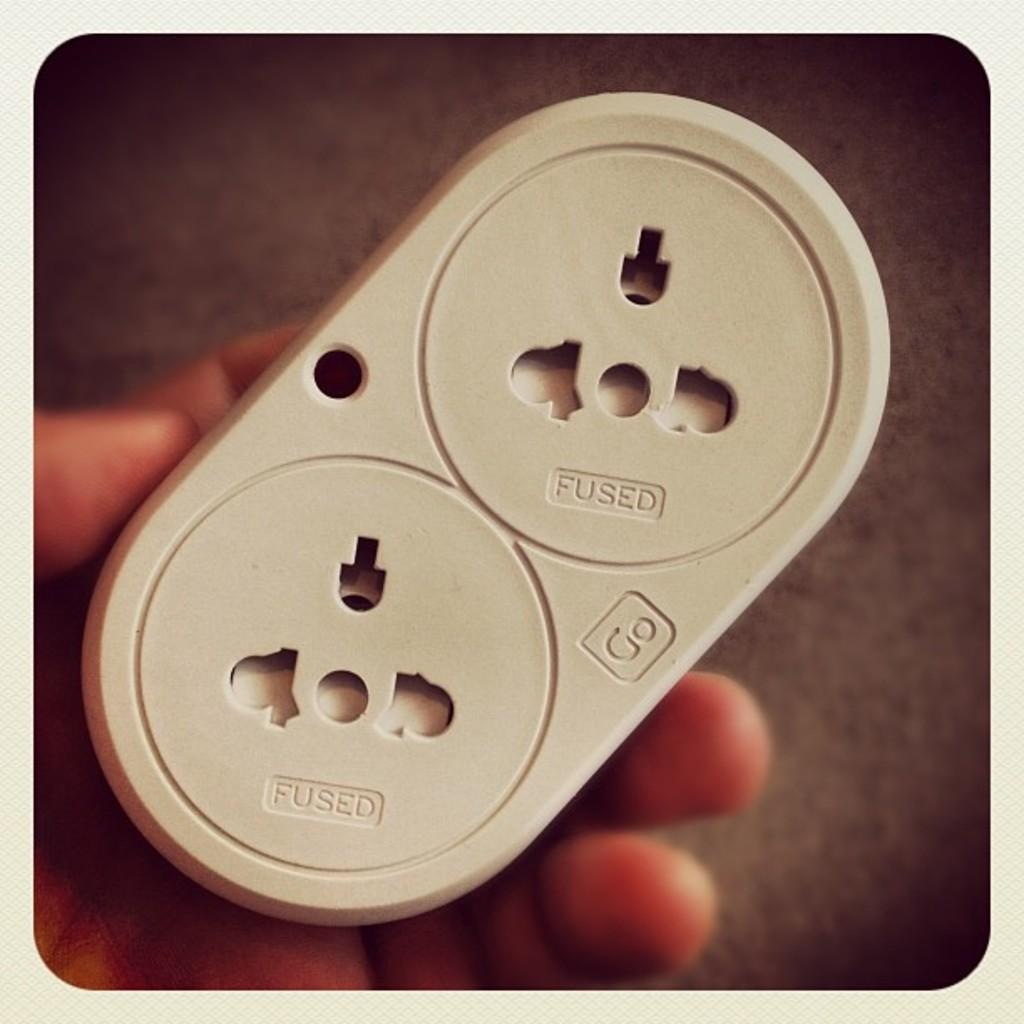Provide a one-sentence caption for the provided image. A hand holds a device that says Fused and Go on it. 